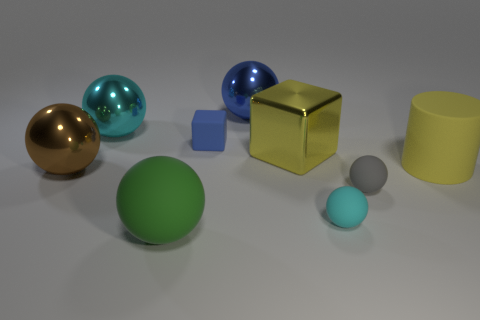Are there fewer cyan metallic balls in front of the big yellow rubber cylinder than spheres behind the big green rubber object?
Your answer should be compact. Yes. What is the shape of the large shiny thing that is the same color as the cylinder?
Ensure brevity in your answer.  Cube. What number of cyan balls are the same size as the gray matte object?
Offer a very short reply. 1. Is the material of the tiny thing that is behind the large cylinder the same as the green thing?
Give a very brief answer. Yes. There is a brown object that is the same material as the blue sphere; what is its size?
Ensure brevity in your answer.  Large. Are there any metallic balls of the same color as the tiny cube?
Ensure brevity in your answer.  Yes. Does the big thing that is right of the tiny cyan rubber thing have the same color as the metal object that is to the right of the blue metallic sphere?
Your response must be concise. Yes. The thing that is the same color as the big metallic cube is what size?
Your answer should be compact. Large. There is a metallic sphere in front of the cyan ball to the left of the shiny sphere to the right of the green rubber sphere; how big is it?
Offer a very short reply. Large. There is a object that is both on the left side of the big rubber sphere and behind the large yellow shiny thing; what is its color?
Make the answer very short. Cyan. 